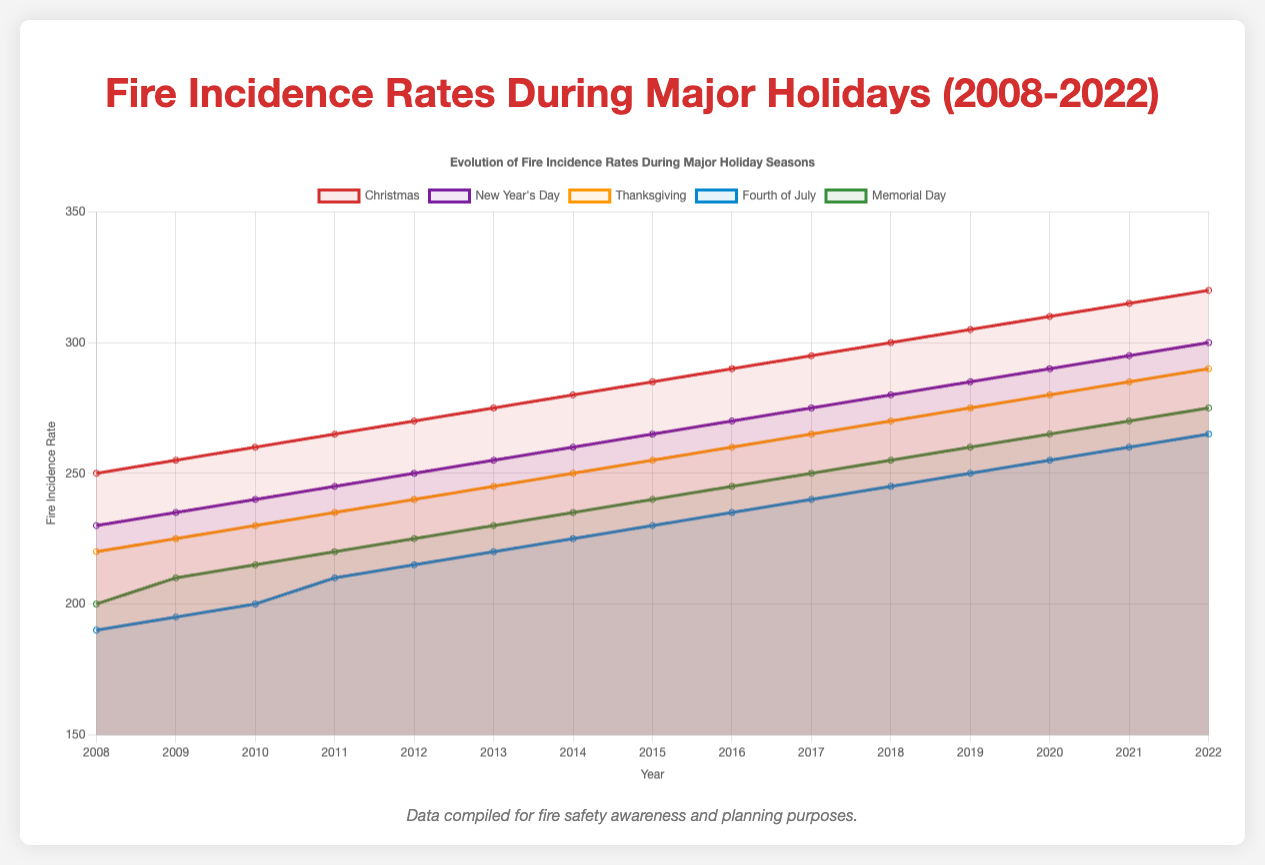Which holiday season consistently has the highest fire incidence rate over the 15-year period? Observing the line plot, the line representing "Christmas" is consistently higher than the lines for other holiday seasons throughout all the years displayed.
Answer: Christmas Compare the fire incidence rates of "New Year's Day" and "Fourth of July" in 2015. Which one is higher and by how much? In 2015, the plot shows the incidence rate for "New Year's Day" as 265 and "Fourth of July" as 230. The difference is 265 - 230 = 35.
Answer: New Year's Day by 35 What is the average fire incidence rate for "Thanksgiving" from 2008 to 2012 inclusive? The incidence rates for "Thanksgiving" from 2008 to 2012 are 220, 225, 230, 235, and 240. Summing these gives 1150. Dividing this by 5 gives 1150 / 5 = 230.
Answer: 230 Which holiday season shows the greatest increase in fire incidence rate from 2008 to 2022? Observing the plot, "Christmas" shows the greatest increase; it started at 250 in 2008 and ended at 320 in 2022, an increase of 70.
Answer: Christmas Between "Memorial Day" and "Thanksgiving," which holiday had a higher fire incidence rate in the year 2011 and what was the difference? In 2011, "Memorial Day" had a fire incidence rate of 220, while "Thanksgiving" had 235. The difference is 235 - 220 = 15.
Answer: Thanksgiving by 15 Looking at the color codes, which holiday season has its fire incidence rate represented by the blue line? The Fourth of July is represented by the blue line in the plot.
Answer: Fourth of July Did the fire incidence rate on "New Year's Day" ever surpass 300 during the 15 years shown? Observing the "New Year's Day" line in the plot, it reaches a maximum of 300 in 2022 but does not surpass it.
Answer: No For "Fourth of July," what is the total number of fire incidences from 2008 to 2022? Summing the incidence rates for "Fourth of July" from 2008 to 2022: 190 + 195 + 200 + 210 + 215 + 220 + 225 + 230 + 235 + 240 + 245 + 250 + 255 + 260 + 265 = 3495.
Answer: 3495 